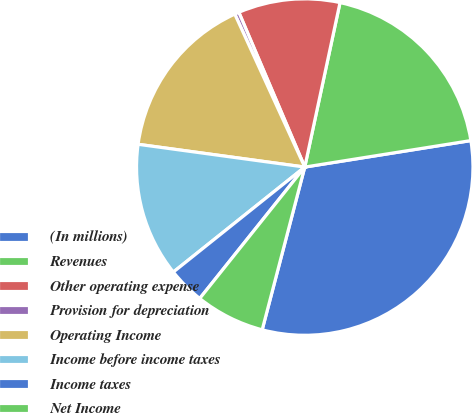Convert chart to OTSL. <chart><loc_0><loc_0><loc_500><loc_500><pie_chart><fcel>(In millions)<fcel>Revenues<fcel>Other operating expense<fcel>Provision for depreciation<fcel>Operating Income<fcel>Income before income taxes<fcel>Income taxes<fcel>Net Income<nl><fcel>31.59%<fcel>19.12%<fcel>9.77%<fcel>0.42%<fcel>16.01%<fcel>12.89%<fcel>3.54%<fcel>6.66%<nl></chart> 